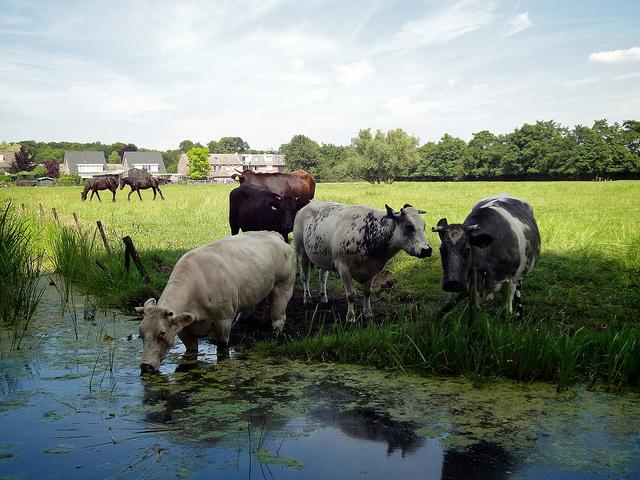How many horns does the cow have?
Concise answer only. 2. How many of these bulls are drinking?
Be succinct. 1. What are the buildings in the background used for?
Quick response, please. Housing. What is dividing the water and grass?
Keep it brief. Fence. Are all the bulls the same color?
Be succinct. No. 